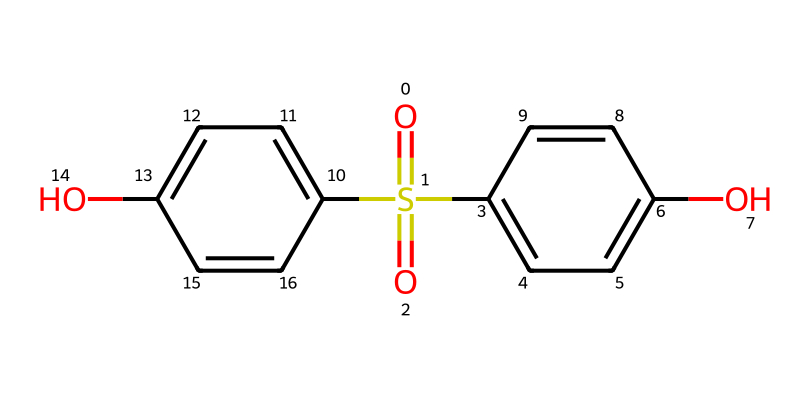What is the molecular formula for the compound represented by the SMILES? By analyzing the given SMILES representation, we can identify the individual atoms present. In the compound, we observe carbon (C), hydrogen (H), oxygen (O), and sulfur (S) atoms. Counting the atoms, we find: 12 carbons, 12 hydrogens, 4 oxygens, and 1 sulfur. Therefore, the molecular formula is C12H12O4S.
Answer: C12H12O4S How many hydroxyl groups (-OH) are present in this compound? In the structure derived from the SMILES, we can identify hydroxyl groups by locating the -OH attachments. There are two -OH groups attached to aromatic rings in the structure. Hence, the count of hydroxyl groups is 2.
Answer: 2 What type of functional group is emphasized in this phenol? In the given chemical structure, the hydroxyl groups (-OH) directly bonded to aromatic rings indicate that this compound is a phenol. Furthermore, the presence of sulfur and various other components reinforces that it belongs to the category of phenolic compounds.
Answer: phenol Which element indicates the presence of a sulfonyl group in this structure? The presence of the sulfur atom bonded to oxygen atoms signifies the sulfonyl group. This is observable in the structure derived from the SMILES, where sulfur is double bonded to one oxygen and single bonded to two others. Thus, the element indicating the sulfonyl group is sulfur.
Answer: sulfur How many aromatic rings are present in this molecule? When analyzing the structure derived from the SMILES representation, we can identify the distinct aromatic rings. In this case, there are two separate aromatic rings connected to the core structure. Thus, the total number of aromatic rings in this molecule is 2.
Answer: 2 Why might this compound be considered an alternative to BPA? This compound has similar structural properties to bisphenol A (BPA) but lacks the concerning characteristics typically associated with BPA, such as endocrine disruption. The inclusion of hydroxyl and sulfonyl functional groups might contribute to its favorable characteristics while avoiding the potential toxicity associated with BPA. Therefore, it can be viewed as a safer alternative.
Answer: safer alternative 